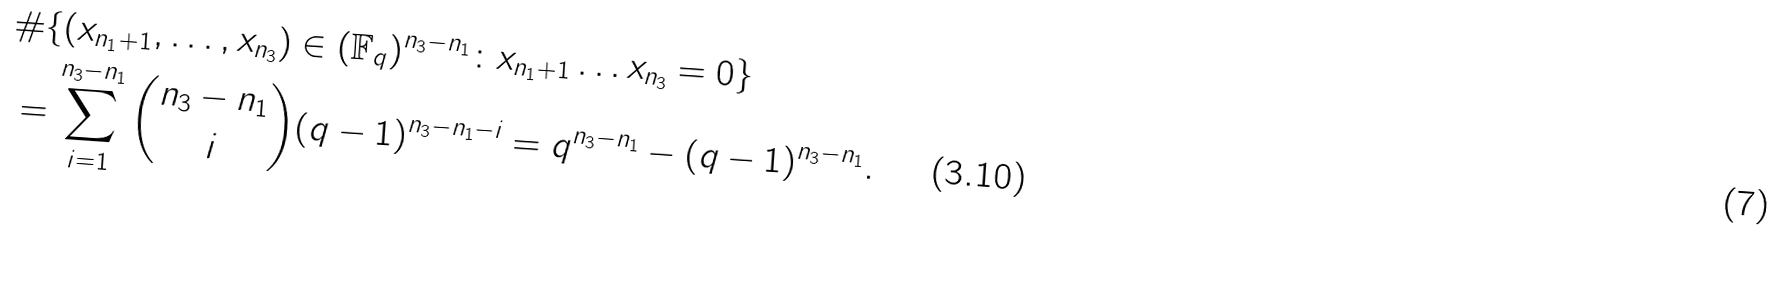<formula> <loc_0><loc_0><loc_500><loc_500>& \# \{ ( x _ { n _ { 1 } + 1 } , \dots , x _ { n _ { 3 } } ) \in ( \mathbb { F } _ { q } ) ^ { n _ { 3 } - n _ { 1 } } \colon x _ { n _ { 1 } + 1 } \dots x _ { n _ { 3 } } = 0 \} \\ & = \sum _ { i = 1 } ^ { n _ { 3 } - n _ { 1 } } { n _ { 3 } - n _ { 1 } \choose i } ( q - 1 ) ^ { n _ { 3 } - n _ { 1 } - i } = q ^ { n _ { 3 } - n _ { 1 } } - ( q - 1 ) ^ { n _ { 3 } - n _ { 1 } } . \quad \ \ ( 3 . 1 0 )</formula> 